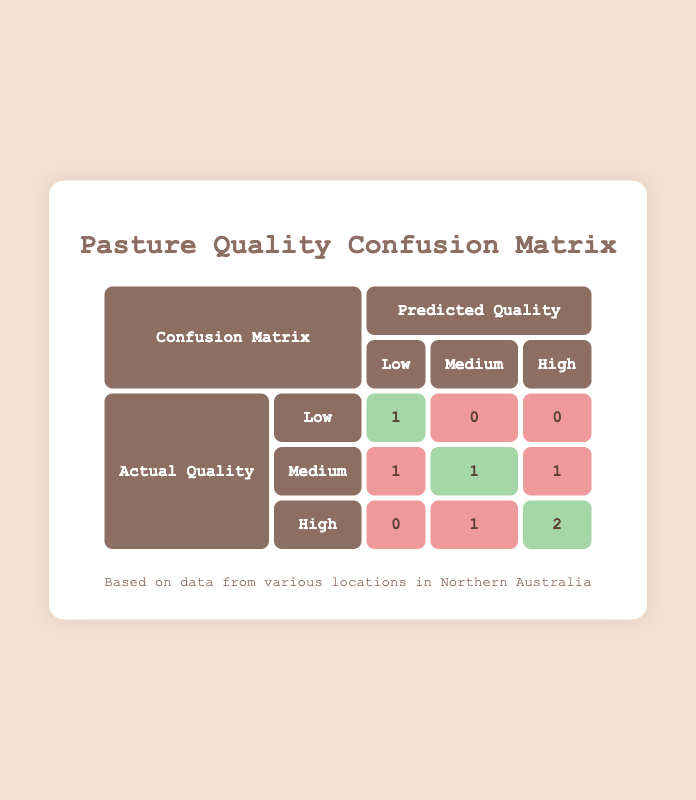What is the number of instances where the predicted quality was Low and the actual quality was Low? There is a single entry in the table where the predicted quality is Low, and the actual quality is also Low, specifically for Tennant Creek in July.
Answer: 1 How many times was Medium predicted, regardless of the actual quality? By looking at the table, there are three instances where Medium was predicted: one for Katherine (Medium/Medium), one for Broome (Medium/High), and one for Longreach (Medium/Low). Thus, the total is three.
Answer: 3 Did the prediction correctly identify the High-quality pasture when the actual quality was High? Checking the entries where the actual quality is High, there are two correct predictions: one for Darwin and one for Mt Isa. Therefore, it can be concluded that yes, High-quality pasture was correctly predicted.
Answer: Yes What is the total count of incorrect Medium predictions? The incorrect Medium predictions occur in two scenarios: where actual quality is Medium but predicted as Low (1 instance) and where actual quality is High but predicted as Medium (1 instance). Adding these, the total is two incorrect Medium predictions.
Answer: 2 How many instances showed a correct prediction of Low for actual Low quality? There is only one instance in the table where actual quality is Low and it was correctly predicted as Low. That entry is from Tennant Creek in July.
Answer: 1 When the actual quality was Medium, what was the predicted quality in those instances? There are two entries with actual quality Medium: one is predicted as Low (Longreach) and the other as Medium (Alice Springs), making the predicted qualities Low and Medium, respectively.
Answer: Low and Medium What specific month had the highest number of correct predictions for High quality? The month of August shows the highest number of correct predictions for High quality, as two instances (Darwin and Mt Isa) had correct predictions compared to others.
Answer: August Were there any instances where the predicted quality was Low while the actual quality was High? Looking at the table, there are no instances where Low was predicted with an actual quality of High; all the predictions align differently.
Answer: No How many overall correct predictions were made in this dataset? The correct predictions can be identified by counting the instances where predicted quality matches actual quality: 1 (Low), 1 (Medium), and 2 (High), totaling 4 correct predictions overall.
Answer: 4 